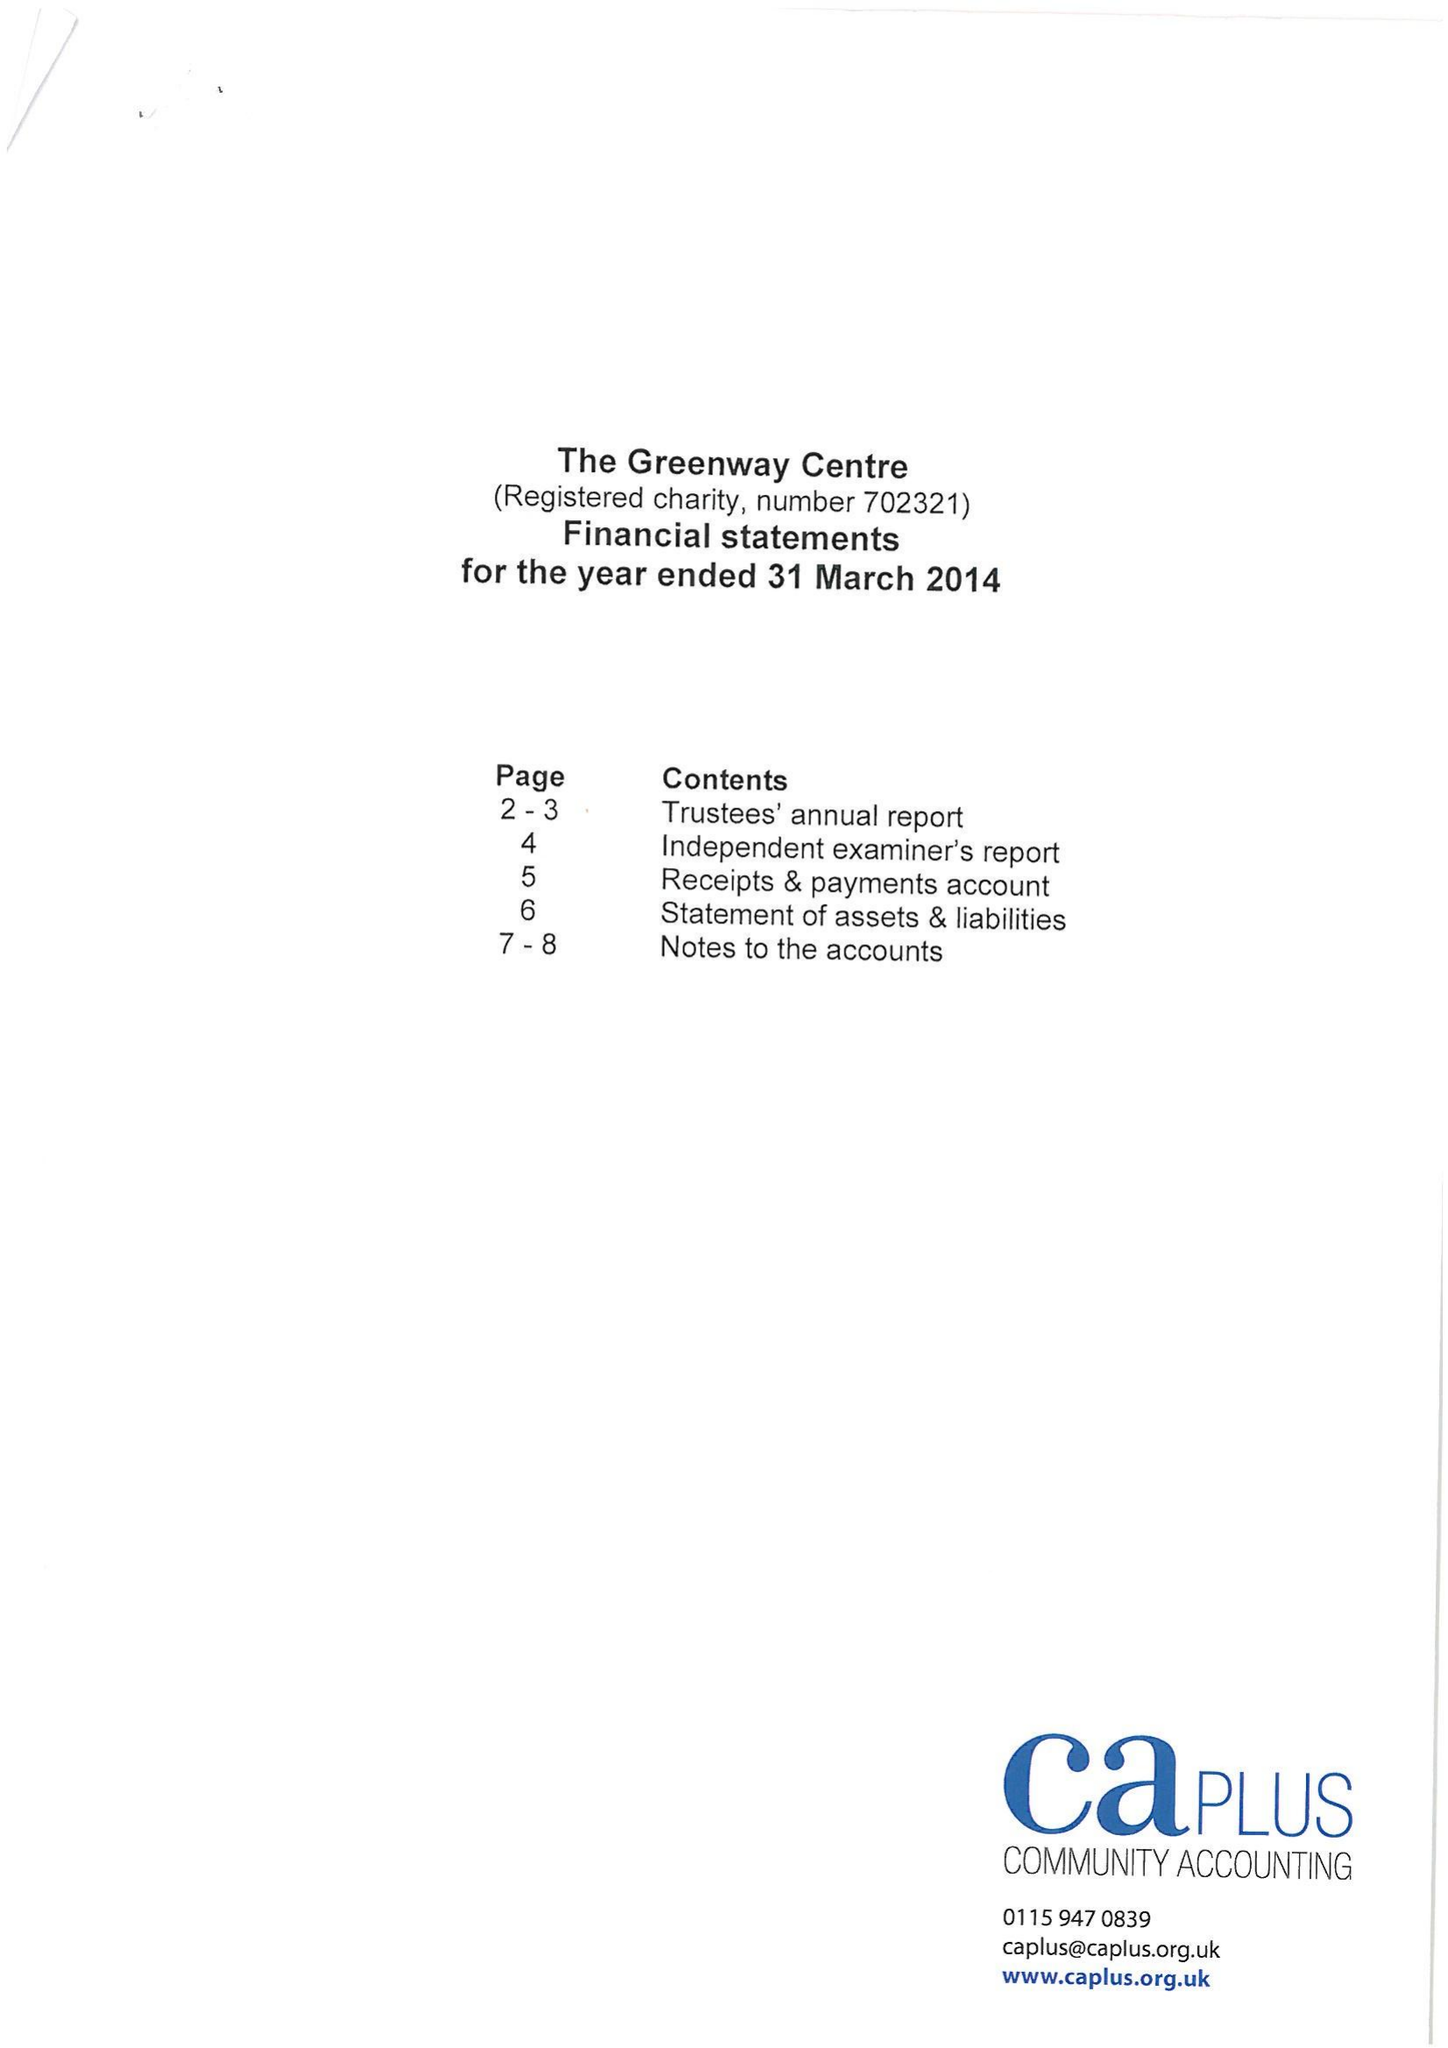What is the value for the charity_name?
Answer the question using a single word or phrase. The Greenway Centre 